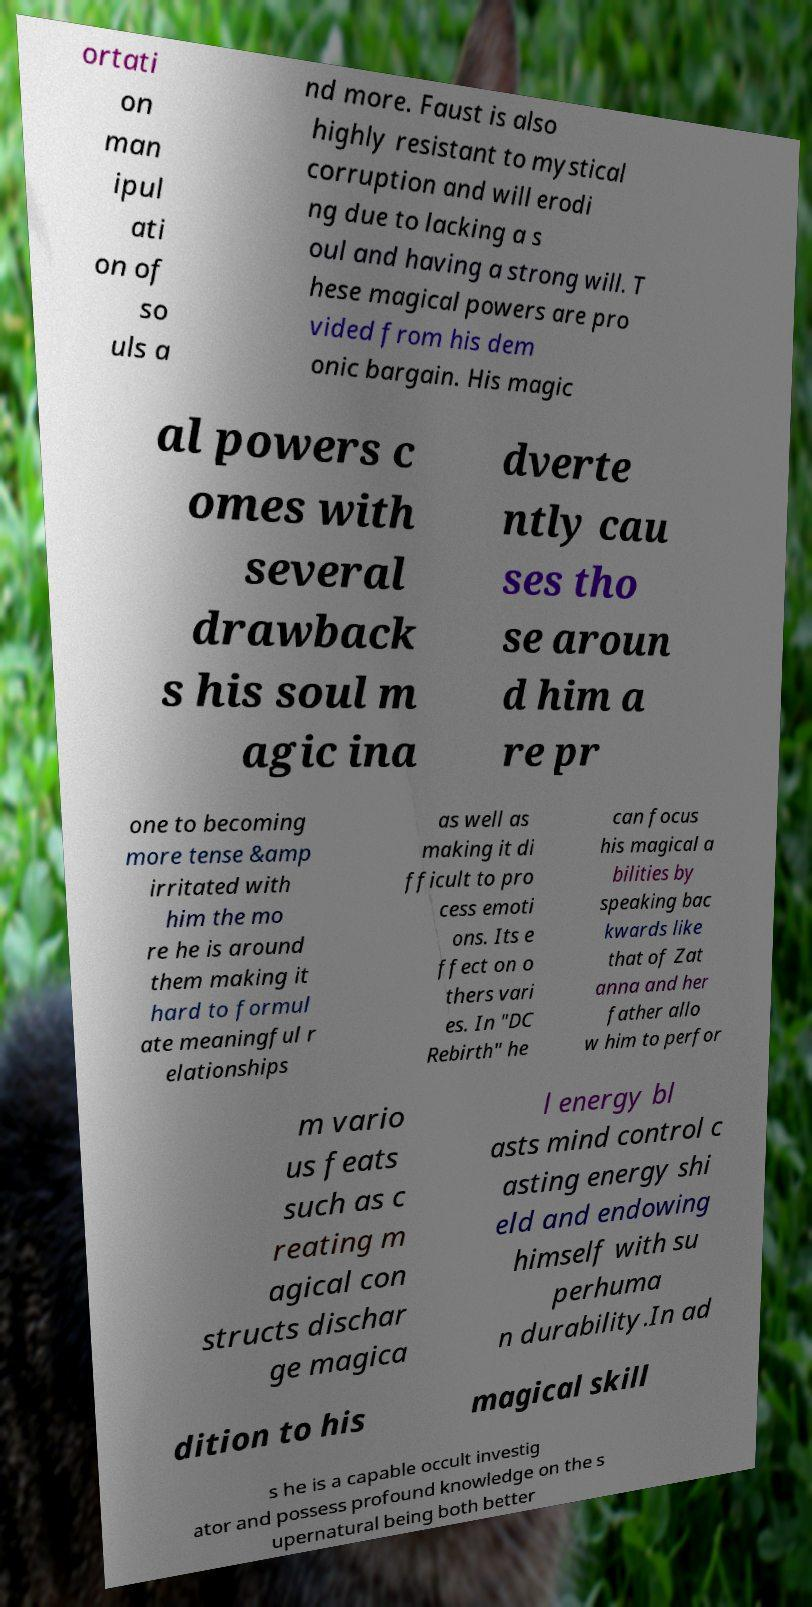I need the written content from this picture converted into text. Can you do that? ortati on man ipul ati on of so uls a nd more. Faust is also highly resistant to mystical corruption and will erodi ng due to lacking a s oul and having a strong will. T hese magical powers are pro vided from his dem onic bargain. His magic al powers c omes with several drawback s his soul m agic ina dverte ntly cau ses tho se aroun d him a re pr one to becoming more tense &amp irritated with him the mo re he is around them making it hard to formul ate meaningful r elationships as well as making it di fficult to pro cess emoti ons. Its e ffect on o thers vari es. In "DC Rebirth" he can focus his magical a bilities by speaking bac kwards like that of Zat anna and her father allo w him to perfor m vario us feats such as c reating m agical con structs dischar ge magica l energy bl asts mind control c asting energy shi eld and endowing himself with su perhuma n durability.In ad dition to his magical skill s he is a capable occult investig ator and possess profound knowledge on the s upernatural being both better 